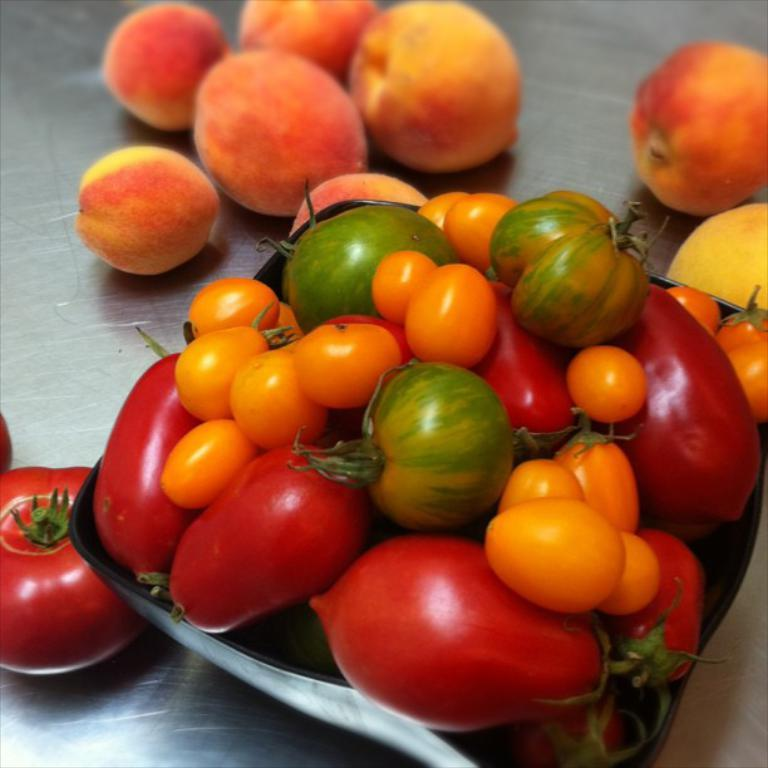What type of fruit is in the black bowl in the foreground of the image? There are tomatoes in a black bowl in the foreground of the image. What is the surface material of the area where the tomato and peaches are placed? The surface material is steel. What other type of fruit is present in the image? There are peaches on a steel surface in the image. How many legs does the kite have in the image? There is no kite present in the image. 